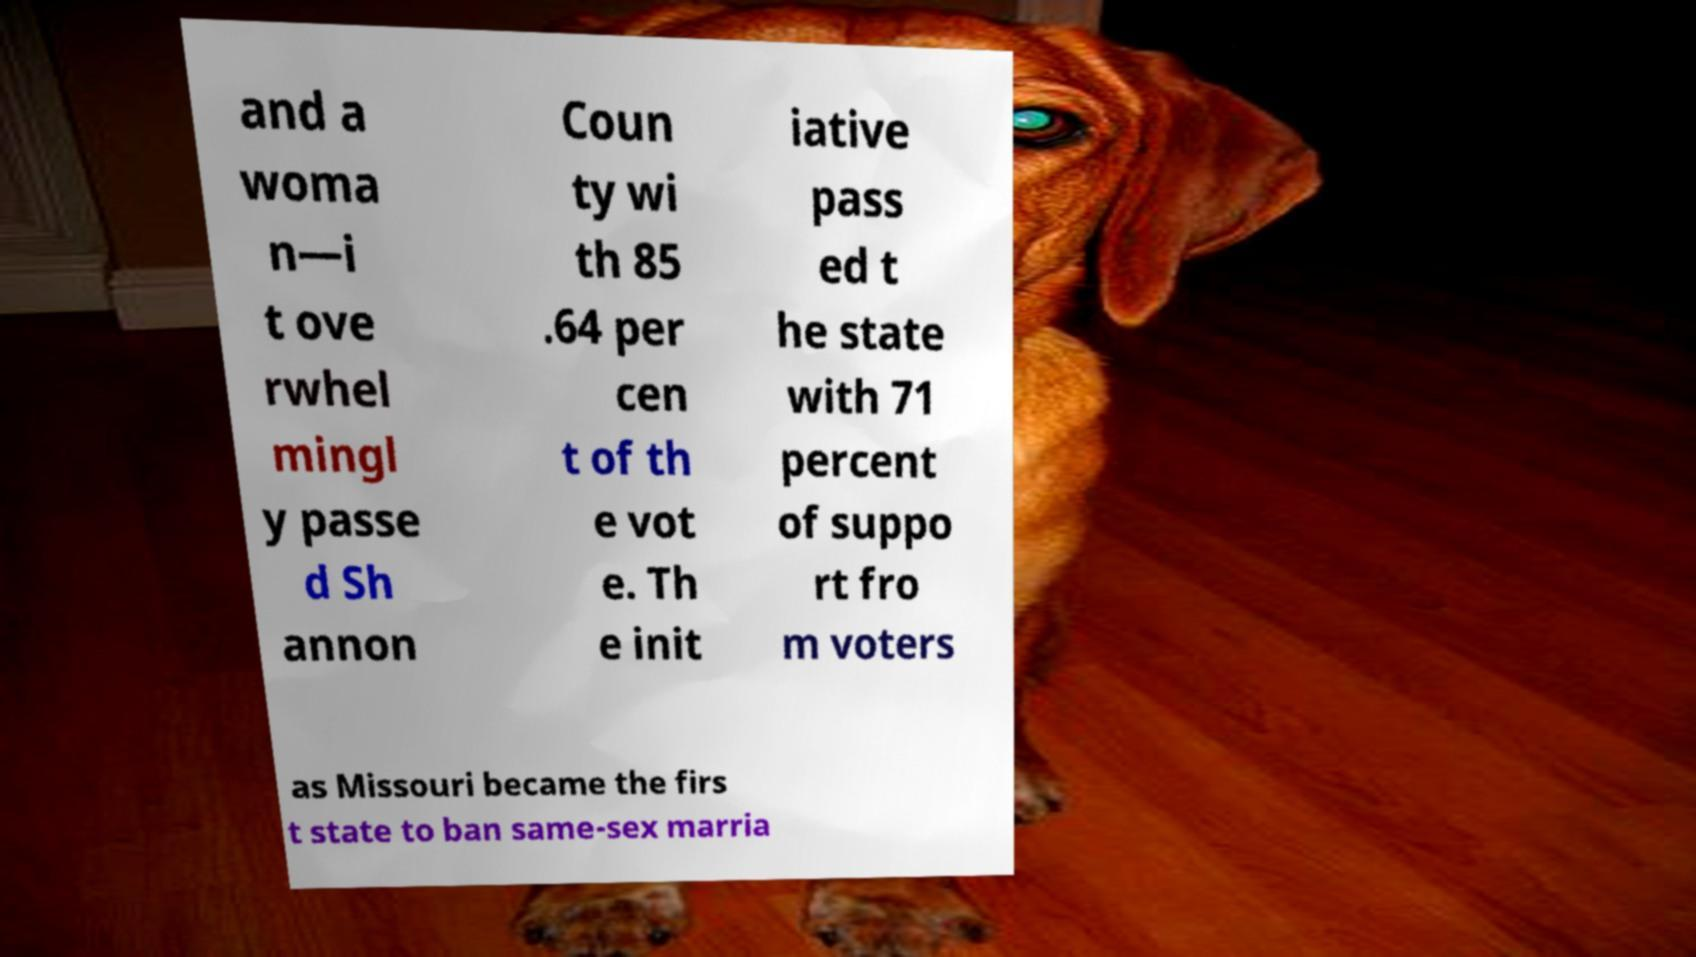There's text embedded in this image that I need extracted. Can you transcribe it verbatim? and a woma n—i t ove rwhel mingl y passe d Sh annon Coun ty wi th 85 .64 per cen t of th e vot e. Th e init iative pass ed t he state with 71 percent of suppo rt fro m voters as Missouri became the firs t state to ban same-sex marria 